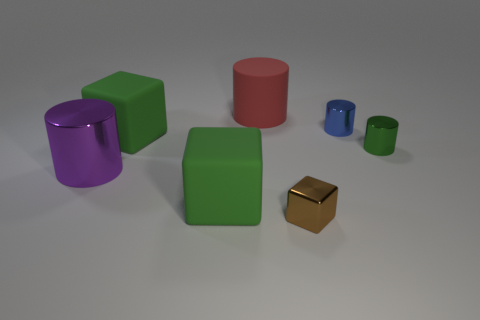Does the large purple cylinder have the same material as the green object right of the metallic block?
Your answer should be compact. Yes. There is a green rubber object behind the metal object to the left of the brown block; how many large green matte things are in front of it?
Your response must be concise. 1. There is a blue metallic object; is it the same shape as the green thing that is right of the big red matte object?
Give a very brief answer. Yes. There is a large object that is both in front of the green cylinder and to the right of the purple cylinder; what color is it?
Your response must be concise. Green. There is a big green cube that is left of the green thing that is in front of the cylinder that is left of the red matte cylinder; what is its material?
Provide a short and direct response. Rubber. What material is the tiny blue cylinder?
Your response must be concise. Metal. There is a red rubber thing that is the same shape as the tiny green metal object; what size is it?
Your answer should be compact. Large. Is the small shiny cube the same color as the large metallic cylinder?
Make the answer very short. No. How many other things are there of the same material as the tiny brown thing?
Provide a succinct answer. 3. Is the number of big green matte cubes in front of the brown cube the same as the number of brown things?
Your answer should be compact. No. 